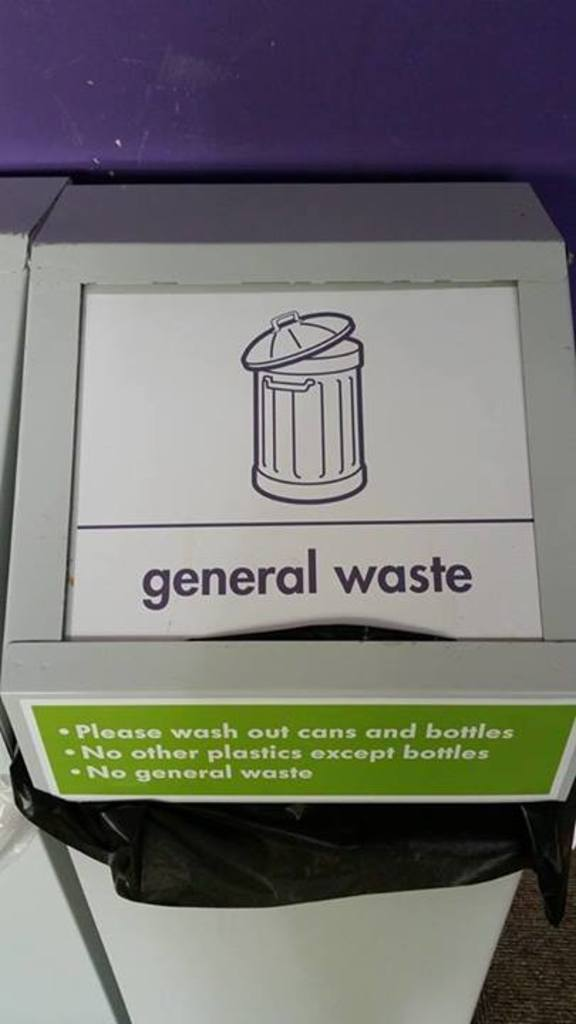How does washing out cans and bottles help in recycling? Washing out cans and bottles removes residual food and liquids, which can contaminate other recyclables and interfere with the recycling process. Clean recyclables are more likely to be successfully processed and reused, reducing the overall environmental impact of waste. 